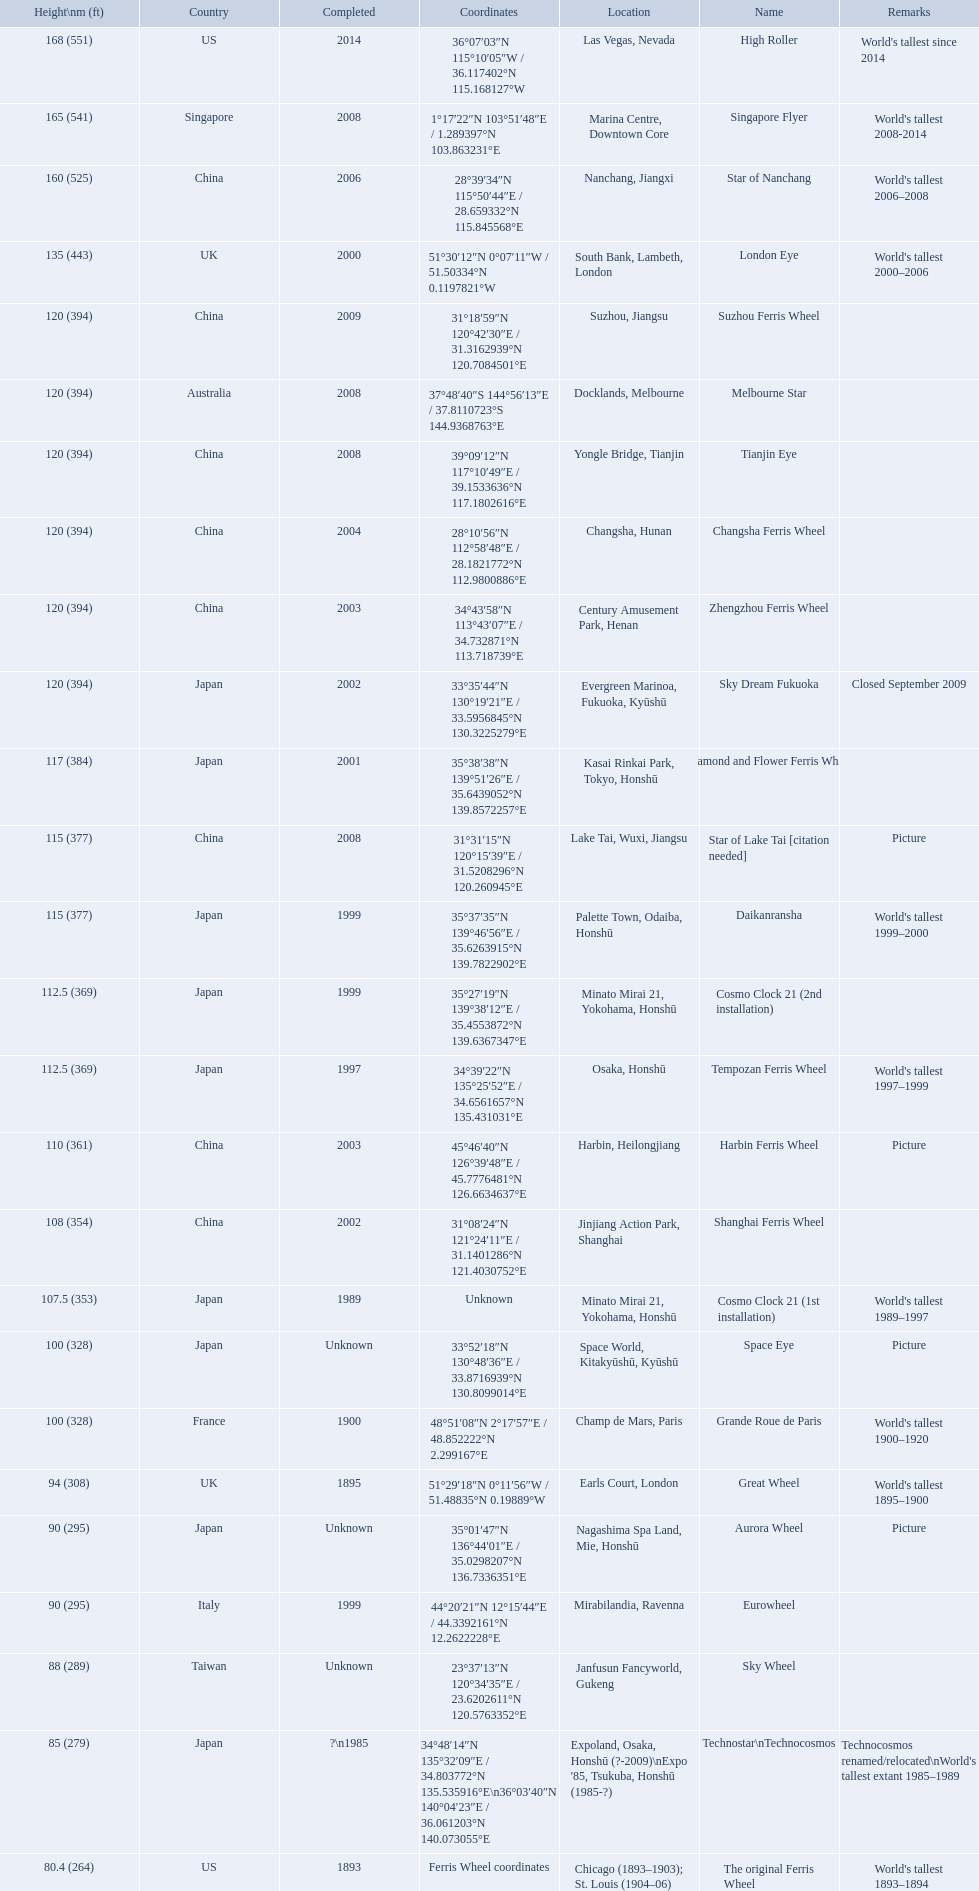What are the different completion dates for the ferris wheel list? 2014, 2008, 2006, 2000, 2009, 2008, 2008, 2004, 2003, 2002, 2001, 2008, 1999, 1999, 1997, 2003, 2002, 1989, Unknown, 1900, 1895, Unknown, 1999, Unknown, ?\n1985, 1893. Which dates for the star of lake tai, star of nanchang, melbourne star? 2006, 2008, 2008. Which is the oldest? 2006. What ride name is this for? Star of Nanchang. What ferris wheels were completed in 2008 Singapore Flyer, Melbourne Star, Tianjin Eye, Star of Lake Tai [citation needed]. Of these, which has the height of 165? Singapore Flyer. 